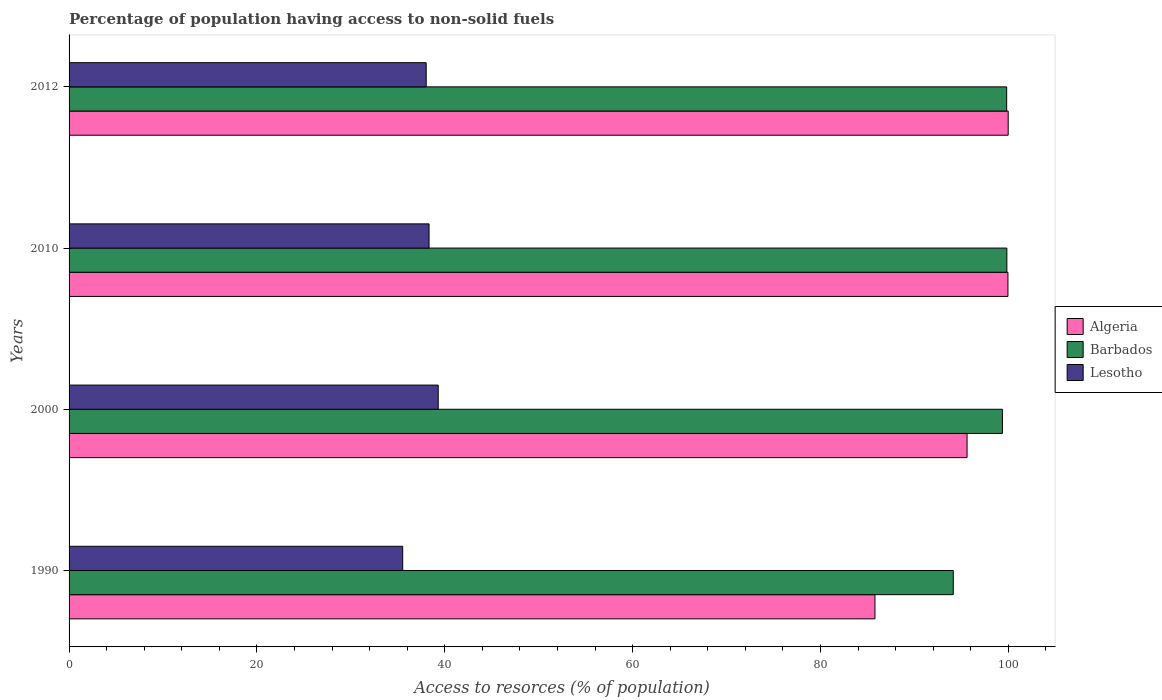How many different coloured bars are there?
Your answer should be compact. 3. How many groups of bars are there?
Offer a very short reply. 4. Are the number of bars per tick equal to the number of legend labels?
Your answer should be compact. Yes. Are the number of bars on each tick of the Y-axis equal?
Provide a short and direct response. Yes. How many bars are there on the 2nd tick from the top?
Ensure brevity in your answer.  3. How many bars are there on the 1st tick from the bottom?
Give a very brief answer. 3. In how many cases, is the number of bars for a given year not equal to the number of legend labels?
Your response must be concise. 0. What is the percentage of population having access to non-solid fuels in Barbados in 2012?
Offer a terse response. 99.83. Across all years, what is the maximum percentage of population having access to non-solid fuels in Lesotho?
Provide a succinct answer. 39.3. Across all years, what is the minimum percentage of population having access to non-solid fuels in Lesotho?
Provide a succinct answer. 35.52. In which year was the percentage of population having access to non-solid fuels in Barbados maximum?
Your response must be concise. 2010. What is the total percentage of population having access to non-solid fuels in Algeria in the graph?
Provide a succinct answer. 381.37. What is the difference between the percentage of population having access to non-solid fuels in Barbados in 2000 and that in 2010?
Provide a short and direct response. -0.47. What is the difference between the percentage of population having access to non-solid fuels in Barbados in 2010 and the percentage of population having access to non-solid fuels in Algeria in 2000?
Your response must be concise. 4.24. What is the average percentage of population having access to non-solid fuels in Algeria per year?
Make the answer very short. 95.34. In the year 2012, what is the difference between the percentage of population having access to non-solid fuels in Algeria and percentage of population having access to non-solid fuels in Lesotho?
Your answer should be compact. 61.97. In how many years, is the percentage of population having access to non-solid fuels in Barbados greater than 100 %?
Your answer should be compact. 0. What is the ratio of the percentage of population having access to non-solid fuels in Lesotho in 1990 to that in 2010?
Give a very brief answer. 0.93. Is the difference between the percentage of population having access to non-solid fuels in Algeria in 1990 and 2012 greater than the difference between the percentage of population having access to non-solid fuels in Lesotho in 1990 and 2012?
Your answer should be compact. No. What is the difference between the highest and the second highest percentage of population having access to non-solid fuels in Algeria?
Make the answer very short. 0.03. What is the difference between the highest and the lowest percentage of population having access to non-solid fuels in Algeria?
Offer a very short reply. 14.19. In how many years, is the percentage of population having access to non-solid fuels in Algeria greater than the average percentage of population having access to non-solid fuels in Algeria taken over all years?
Your answer should be compact. 3. Is the sum of the percentage of population having access to non-solid fuels in Algeria in 1990 and 2012 greater than the maximum percentage of population having access to non-solid fuels in Lesotho across all years?
Your response must be concise. Yes. What does the 3rd bar from the top in 2010 represents?
Give a very brief answer. Algeria. What does the 2nd bar from the bottom in 2010 represents?
Ensure brevity in your answer.  Barbados. How many bars are there?
Your answer should be very brief. 12. How many years are there in the graph?
Your response must be concise. 4. Are the values on the major ticks of X-axis written in scientific E-notation?
Offer a terse response. No. Does the graph contain grids?
Give a very brief answer. No. How are the legend labels stacked?
Offer a very short reply. Vertical. What is the title of the graph?
Provide a short and direct response. Percentage of population having access to non-solid fuels. What is the label or title of the X-axis?
Your answer should be very brief. Access to resorces (% of population). What is the Access to resorces (% of population) of Algeria in 1990?
Provide a short and direct response. 85.8. What is the Access to resorces (% of population) in Barbados in 1990?
Your answer should be very brief. 94.14. What is the Access to resorces (% of population) of Lesotho in 1990?
Ensure brevity in your answer.  35.52. What is the Access to resorces (% of population) of Algeria in 2000?
Ensure brevity in your answer.  95.61. What is the Access to resorces (% of population) in Barbados in 2000?
Provide a succinct answer. 99.38. What is the Access to resorces (% of population) in Lesotho in 2000?
Your answer should be very brief. 39.3. What is the Access to resorces (% of population) of Algeria in 2010?
Ensure brevity in your answer.  99.96. What is the Access to resorces (% of population) of Barbados in 2010?
Provide a succinct answer. 99.85. What is the Access to resorces (% of population) of Lesotho in 2010?
Give a very brief answer. 38.33. What is the Access to resorces (% of population) in Algeria in 2012?
Offer a very short reply. 99.99. What is the Access to resorces (% of population) of Barbados in 2012?
Ensure brevity in your answer.  99.83. What is the Access to resorces (% of population) in Lesotho in 2012?
Your response must be concise. 38.02. Across all years, what is the maximum Access to resorces (% of population) of Algeria?
Your answer should be very brief. 99.99. Across all years, what is the maximum Access to resorces (% of population) of Barbados?
Give a very brief answer. 99.85. Across all years, what is the maximum Access to resorces (% of population) in Lesotho?
Make the answer very short. 39.3. Across all years, what is the minimum Access to resorces (% of population) of Algeria?
Provide a short and direct response. 85.8. Across all years, what is the minimum Access to resorces (% of population) of Barbados?
Give a very brief answer. 94.14. Across all years, what is the minimum Access to resorces (% of population) of Lesotho?
Keep it short and to the point. 35.52. What is the total Access to resorces (% of population) in Algeria in the graph?
Ensure brevity in your answer.  381.37. What is the total Access to resorces (% of population) of Barbados in the graph?
Offer a very short reply. 393.2. What is the total Access to resorces (% of population) of Lesotho in the graph?
Make the answer very short. 151.18. What is the difference between the Access to resorces (% of population) in Algeria in 1990 and that in 2000?
Offer a terse response. -9.81. What is the difference between the Access to resorces (% of population) of Barbados in 1990 and that in 2000?
Provide a succinct answer. -5.23. What is the difference between the Access to resorces (% of population) in Lesotho in 1990 and that in 2000?
Offer a very short reply. -3.78. What is the difference between the Access to resorces (% of population) in Algeria in 1990 and that in 2010?
Your answer should be compact. -14.16. What is the difference between the Access to resorces (% of population) of Barbados in 1990 and that in 2010?
Ensure brevity in your answer.  -5.7. What is the difference between the Access to resorces (% of population) of Lesotho in 1990 and that in 2010?
Ensure brevity in your answer.  -2.81. What is the difference between the Access to resorces (% of population) in Algeria in 1990 and that in 2012?
Offer a very short reply. -14.19. What is the difference between the Access to resorces (% of population) in Barbados in 1990 and that in 2012?
Your response must be concise. -5.68. What is the difference between the Access to resorces (% of population) in Lesotho in 1990 and that in 2012?
Offer a very short reply. -2.5. What is the difference between the Access to resorces (% of population) of Algeria in 2000 and that in 2010?
Provide a succinct answer. -4.35. What is the difference between the Access to resorces (% of population) in Barbados in 2000 and that in 2010?
Provide a short and direct response. -0.47. What is the difference between the Access to resorces (% of population) of Lesotho in 2000 and that in 2010?
Your answer should be very brief. 0.97. What is the difference between the Access to resorces (% of population) of Algeria in 2000 and that in 2012?
Give a very brief answer. -4.38. What is the difference between the Access to resorces (% of population) of Barbados in 2000 and that in 2012?
Make the answer very short. -0.45. What is the difference between the Access to resorces (% of population) in Lesotho in 2000 and that in 2012?
Give a very brief answer. 1.28. What is the difference between the Access to resorces (% of population) of Algeria in 2010 and that in 2012?
Provide a succinct answer. -0.03. What is the difference between the Access to resorces (% of population) in Barbados in 2010 and that in 2012?
Give a very brief answer. 0.02. What is the difference between the Access to resorces (% of population) in Lesotho in 2010 and that in 2012?
Keep it short and to the point. 0.31. What is the difference between the Access to resorces (% of population) in Algeria in 1990 and the Access to resorces (% of population) in Barbados in 2000?
Provide a succinct answer. -13.57. What is the difference between the Access to resorces (% of population) in Algeria in 1990 and the Access to resorces (% of population) in Lesotho in 2000?
Your answer should be compact. 46.5. What is the difference between the Access to resorces (% of population) in Barbados in 1990 and the Access to resorces (% of population) in Lesotho in 2000?
Your answer should be compact. 54.84. What is the difference between the Access to resorces (% of population) of Algeria in 1990 and the Access to resorces (% of population) of Barbados in 2010?
Make the answer very short. -14.04. What is the difference between the Access to resorces (% of population) of Algeria in 1990 and the Access to resorces (% of population) of Lesotho in 2010?
Provide a short and direct response. 47.48. What is the difference between the Access to resorces (% of population) of Barbados in 1990 and the Access to resorces (% of population) of Lesotho in 2010?
Your answer should be very brief. 55.81. What is the difference between the Access to resorces (% of population) of Algeria in 1990 and the Access to resorces (% of population) of Barbados in 2012?
Offer a terse response. -14.02. What is the difference between the Access to resorces (% of population) in Algeria in 1990 and the Access to resorces (% of population) in Lesotho in 2012?
Give a very brief answer. 47.78. What is the difference between the Access to resorces (% of population) of Barbados in 1990 and the Access to resorces (% of population) of Lesotho in 2012?
Offer a terse response. 56.12. What is the difference between the Access to resorces (% of population) of Algeria in 2000 and the Access to resorces (% of population) of Barbados in 2010?
Your answer should be compact. -4.24. What is the difference between the Access to resorces (% of population) of Algeria in 2000 and the Access to resorces (% of population) of Lesotho in 2010?
Offer a terse response. 57.28. What is the difference between the Access to resorces (% of population) in Barbados in 2000 and the Access to resorces (% of population) in Lesotho in 2010?
Ensure brevity in your answer.  61.05. What is the difference between the Access to resorces (% of population) in Algeria in 2000 and the Access to resorces (% of population) in Barbados in 2012?
Offer a very short reply. -4.22. What is the difference between the Access to resorces (% of population) of Algeria in 2000 and the Access to resorces (% of population) of Lesotho in 2012?
Your answer should be very brief. 57.59. What is the difference between the Access to resorces (% of population) in Barbados in 2000 and the Access to resorces (% of population) in Lesotho in 2012?
Keep it short and to the point. 61.36. What is the difference between the Access to resorces (% of population) of Algeria in 2010 and the Access to resorces (% of population) of Barbados in 2012?
Your response must be concise. 0.14. What is the difference between the Access to resorces (% of population) in Algeria in 2010 and the Access to resorces (% of population) in Lesotho in 2012?
Ensure brevity in your answer.  61.94. What is the difference between the Access to resorces (% of population) of Barbados in 2010 and the Access to resorces (% of population) of Lesotho in 2012?
Offer a very short reply. 61.83. What is the average Access to resorces (% of population) of Algeria per year?
Your answer should be very brief. 95.34. What is the average Access to resorces (% of population) in Barbados per year?
Your response must be concise. 98.3. What is the average Access to resorces (% of population) in Lesotho per year?
Make the answer very short. 37.79. In the year 1990, what is the difference between the Access to resorces (% of population) in Algeria and Access to resorces (% of population) in Barbados?
Your answer should be compact. -8.34. In the year 1990, what is the difference between the Access to resorces (% of population) of Algeria and Access to resorces (% of population) of Lesotho?
Keep it short and to the point. 50.28. In the year 1990, what is the difference between the Access to resorces (% of population) of Barbados and Access to resorces (% of population) of Lesotho?
Offer a very short reply. 58.62. In the year 2000, what is the difference between the Access to resorces (% of population) of Algeria and Access to resorces (% of population) of Barbados?
Your answer should be very brief. -3.77. In the year 2000, what is the difference between the Access to resorces (% of population) of Algeria and Access to resorces (% of population) of Lesotho?
Offer a terse response. 56.31. In the year 2000, what is the difference between the Access to resorces (% of population) in Barbados and Access to resorces (% of population) in Lesotho?
Offer a very short reply. 60.08. In the year 2010, what is the difference between the Access to resorces (% of population) in Algeria and Access to resorces (% of population) in Barbados?
Provide a succinct answer. 0.12. In the year 2010, what is the difference between the Access to resorces (% of population) in Algeria and Access to resorces (% of population) in Lesotho?
Offer a terse response. 61.63. In the year 2010, what is the difference between the Access to resorces (% of population) in Barbados and Access to resorces (% of population) in Lesotho?
Provide a short and direct response. 61.52. In the year 2012, what is the difference between the Access to resorces (% of population) in Algeria and Access to resorces (% of population) in Barbados?
Offer a very short reply. 0.16. In the year 2012, what is the difference between the Access to resorces (% of population) in Algeria and Access to resorces (% of population) in Lesotho?
Offer a very short reply. 61.97. In the year 2012, what is the difference between the Access to resorces (% of population) in Barbados and Access to resorces (% of population) in Lesotho?
Provide a succinct answer. 61.8. What is the ratio of the Access to resorces (% of population) of Algeria in 1990 to that in 2000?
Provide a short and direct response. 0.9. What is the ratio of the Access to resorces (% of population) of Barbados in 1990 to that in 2000?
Provide a succinct answer. 0.95. What is the ratio of the Access to resorces (% of population) in Lesotho in 1990 to that in 2000?
Provide a short and direct response. 0.9. What is the ratio of the Access to resorces (% of population) of Algeria in 1990 to that in 2010?
Offer a very short reply. 0.86. What is the ratio of the Access to resorces (% of population) of Barbados in 1990 to that in 2010?
Offer a very short reply. 0.94. What is the ratio of the Access to resorces (% of population) in Lesotho in 1990 to that in 2010?
Ensure brevity in your answer.  0.93. What is the ratio of the Access to resorces (% of population) of Algeria in 1990 to that in 2012?
Your answer should be very brief. 0.86. What is the ratio of the Access to resorces (% of population) of Barbados in 1990 to that in 2012?
Give a very brief answer. 0.94. What is the ratio of the Access to resorces (% of population) of Lesotho in 1990 to that in 2012?
Ensure brevity in your answer.  0.93. What is the ratio of the Access to resorces (% of population) of Algeria in 2000 to that in 2010?
Your answer should be compact. 0.96. What is the ratio of the Access to resorces (% of population) in Barbados in 2000 to that in 2010?
Your response must be concise. 1. What is the ratio of the Access to resorces (% of population) in Lesotho in 2000 to that in 2010?
Provide a succinct answer. 1.03. What is the ratio of the Access to resorces (% of population) in Algeria in 2000 to that in 2012?
Your response must be concise. 0.96. What is the ratio of the Access to resorces (% of population) of Barbados in 2000 to that in 2012?
Your answer should be compact. 1. What is the ratio of the Access to resorces (% of population) of Lesotho in 2000 to that in 2012?
Your response must be concise. 1.03. What is the ratio of the Access to resorces (% of population) of Barbados in 2010 to that in 2012?
Your answer should be very brief. 1. What is the ratio of the Access to resorces (% of population) of Lesotho in 2010 to that in 2012?
Your answer should be compact. 1.01. What is the difference between the highest and the second highest Access to resorces (% of population) of Algeria?
Offer a terse response. 0.03. What is the difference between the highest and the second highest Access to resorces (% of population) in Barbados?
Keep it short and to the point. 0.02. What is the difference between the highest and the second highest Access to resorces (% of population) in Lesotho?
Your answer should be very brief. 0.97. What is the difference between the highest and the lowest Access to resorces (% of population) of Algeria?
Offer a very short reply. 14.19. What is the difference between the highest and the lowest Access to resorces (% of population) of Barbados?
Ensure brevity in your answer.  5.7. What is the difference between the highest and the lowest Access to resorces (% of population) in Lesotho?
Keep it short and to the point. 3.78. 